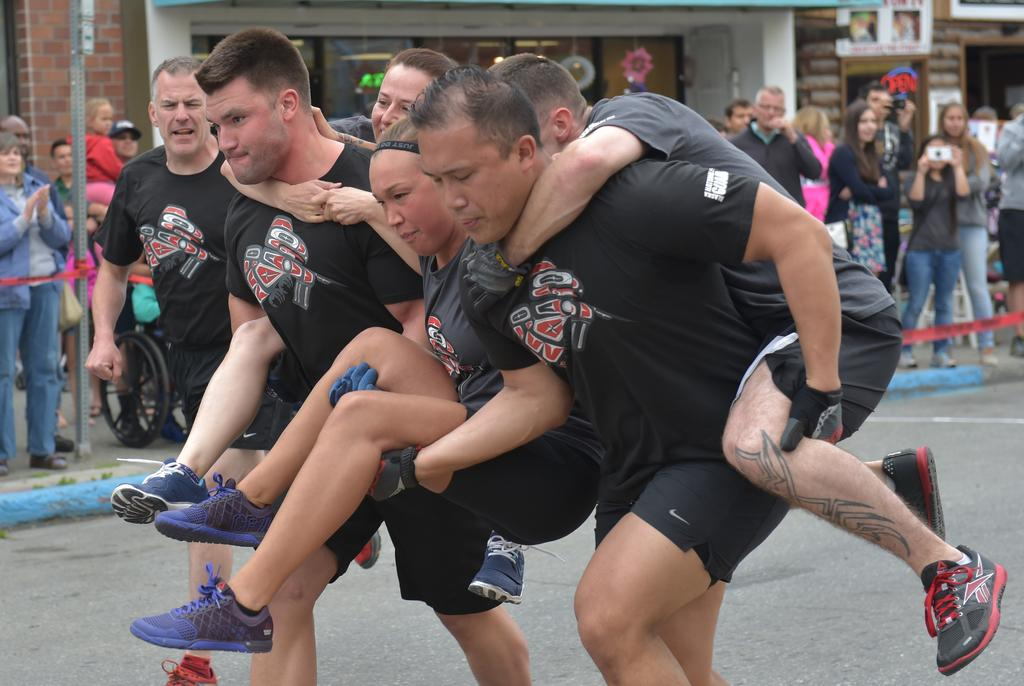How many people are present in the image? There are two men and three other persons in the image, making a total of five people. What are the two men doing in the image? The two men are carrying the other three persons and running on the road. What can be seen in the background of the image? In the background of the image, there is caution tape, poles, a wall, glass doors, objects, and hoardings. What type of noise is being made by the quiver in the image? There is no quiver present in the image, so it is not possible to determine what noise it might make. 